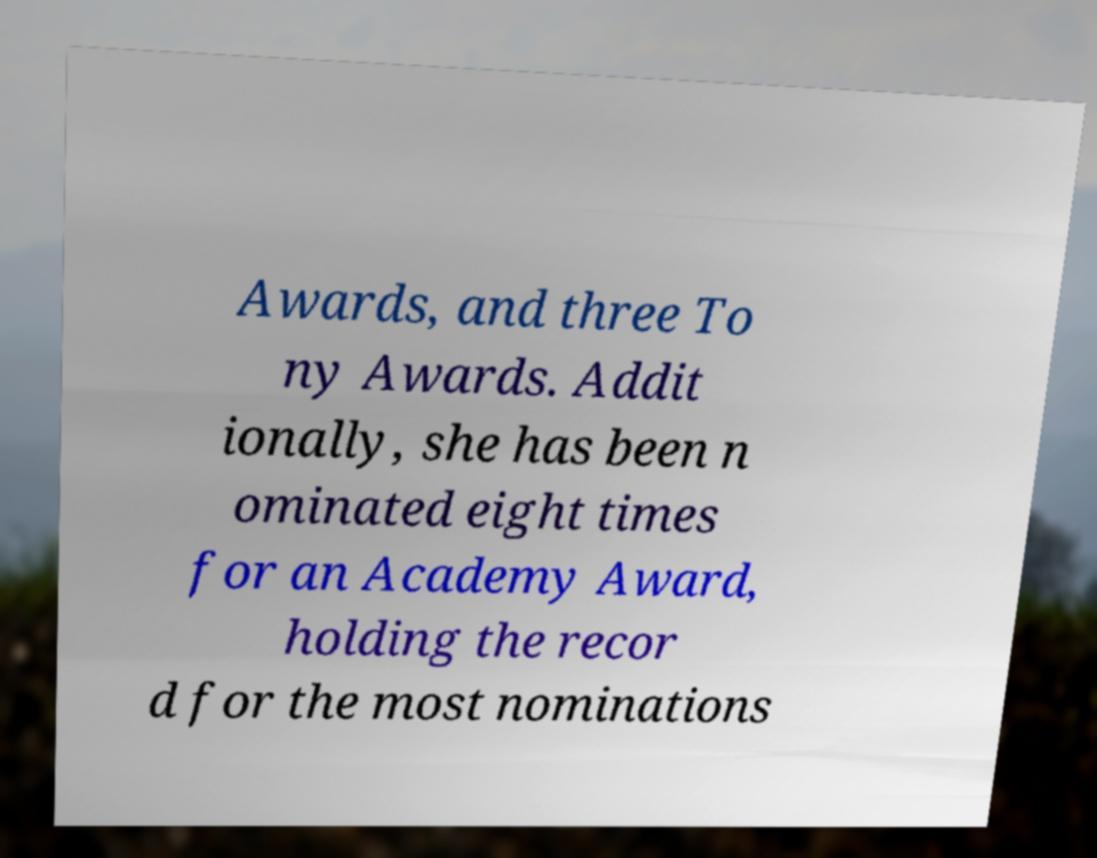I need the written content from this picture converted into text. Can you do that? Awards, and three To ny Awards. Addit ionally, she has been n ominated eight times for an Academy Award, holding the recor d for the most nominations 